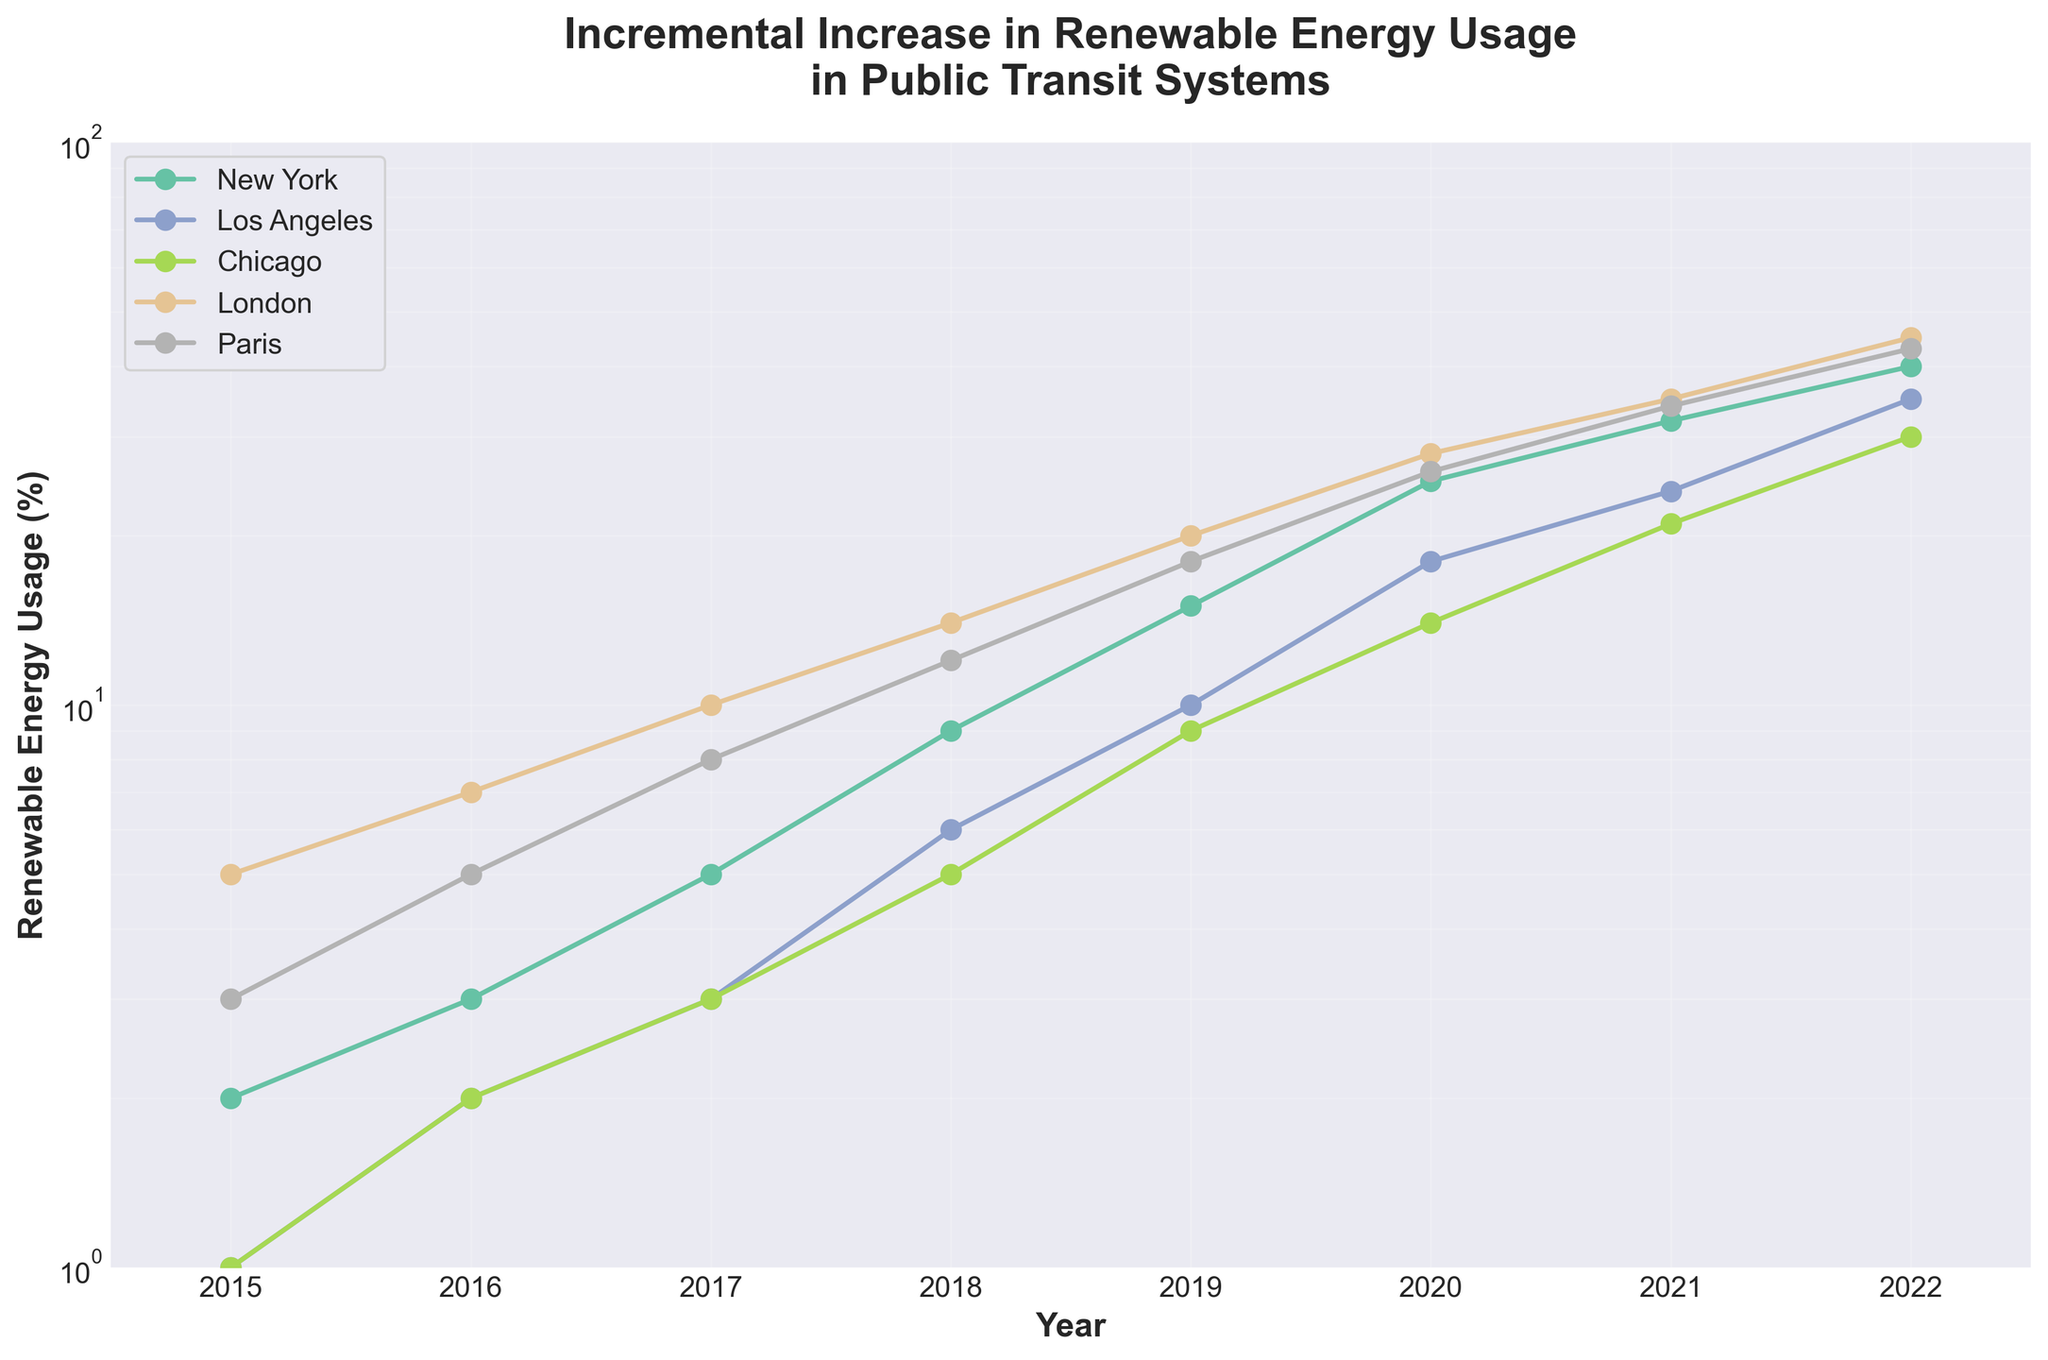What is the title of the figure? The title is usually located at the top of the figure. By reading this, we can understand the overall topic or focus of the data being presented.
Answer: Incremental Increase in Renewable Energy Usage in Public Transit Systems What are the cities compared in this figure? Cities are represented with different lines, each in a unique color and identified in the legend. The legend helps us quickly see which cities are included.
Answer: New York, Los Angeles, Chicago, London, Paris What is the renewable energy usage percentage for New York in 2019? By locating the line for New York on the plot, and then finding the point corresponding to the year 2019, we can read off the y-axis value.
Answer: 15% How many data points are there for each city? Each year from 2015 to 2022 has one data point for each city. By counting these points for one city, we can determine the number for all as the years are consistent.
Answer: 8 Which city had the highest renewable energy usage percentage in 2022? By looking at the data points for the year 2022, we can compare the values on the y-axis for each city and identify the highest one.
Answer: London How has the renewable energy usage changed in New York from 2015 to 2022? We observe the renewable energy usage line for New York from 2015 to 2022 and see its overall trend, noting significant increases over time.
Answer: Increased from 2% to 40% Which city showed the greatest relative increase in renewable energy usage from 2015 to 2022? To determine the relative increase, we compare the starting and ending points for each city and calculate the percentage change for each. Highest relative increase indicates the city with the steepest growth.
Answer: Los Angeles What is the renewable energy usage percentage difference between Paris and Chicago in 2020? By locating the data points for both Paris and Chicago in 2020, we read their y-axis values and compute the difference.
Answer: 26% - 14% = 12% Which year did Los Angeles surpass 10% renewable energy usage? We follow the line for Los Angeles and identify the year where the y-axis value first exceeds 10%.
Answer: 2019 How does the growth trend of renewable energy usage in London compare to Paris? We observe the lines for London and Paris, noting their slopes and overall trajectories from 2015 to 2022 to compare the growth rates and trends.
Answer: London shows a slightly more consistent rise than Paris 